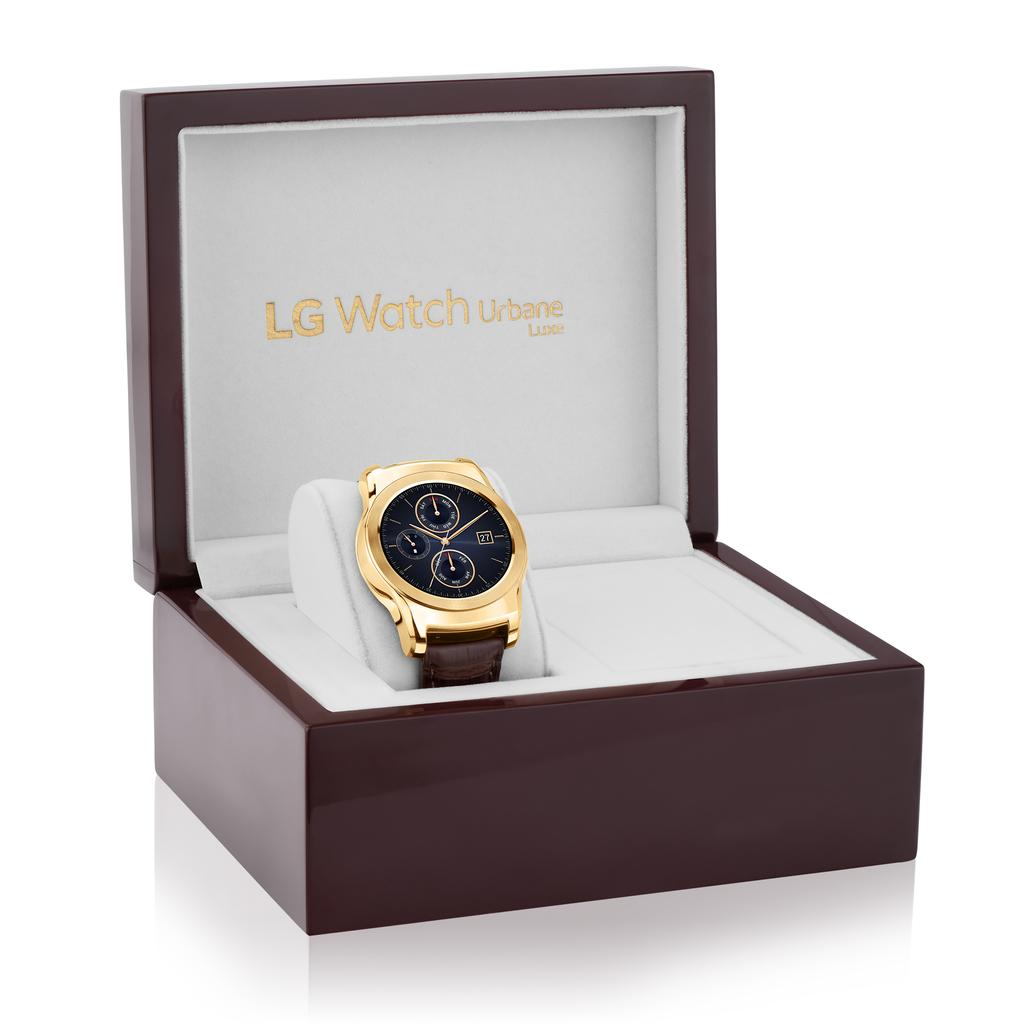Provide a one-sentence caption for the provided image. A luxury watch in a brown box with the logo LG Watch Urbane. 